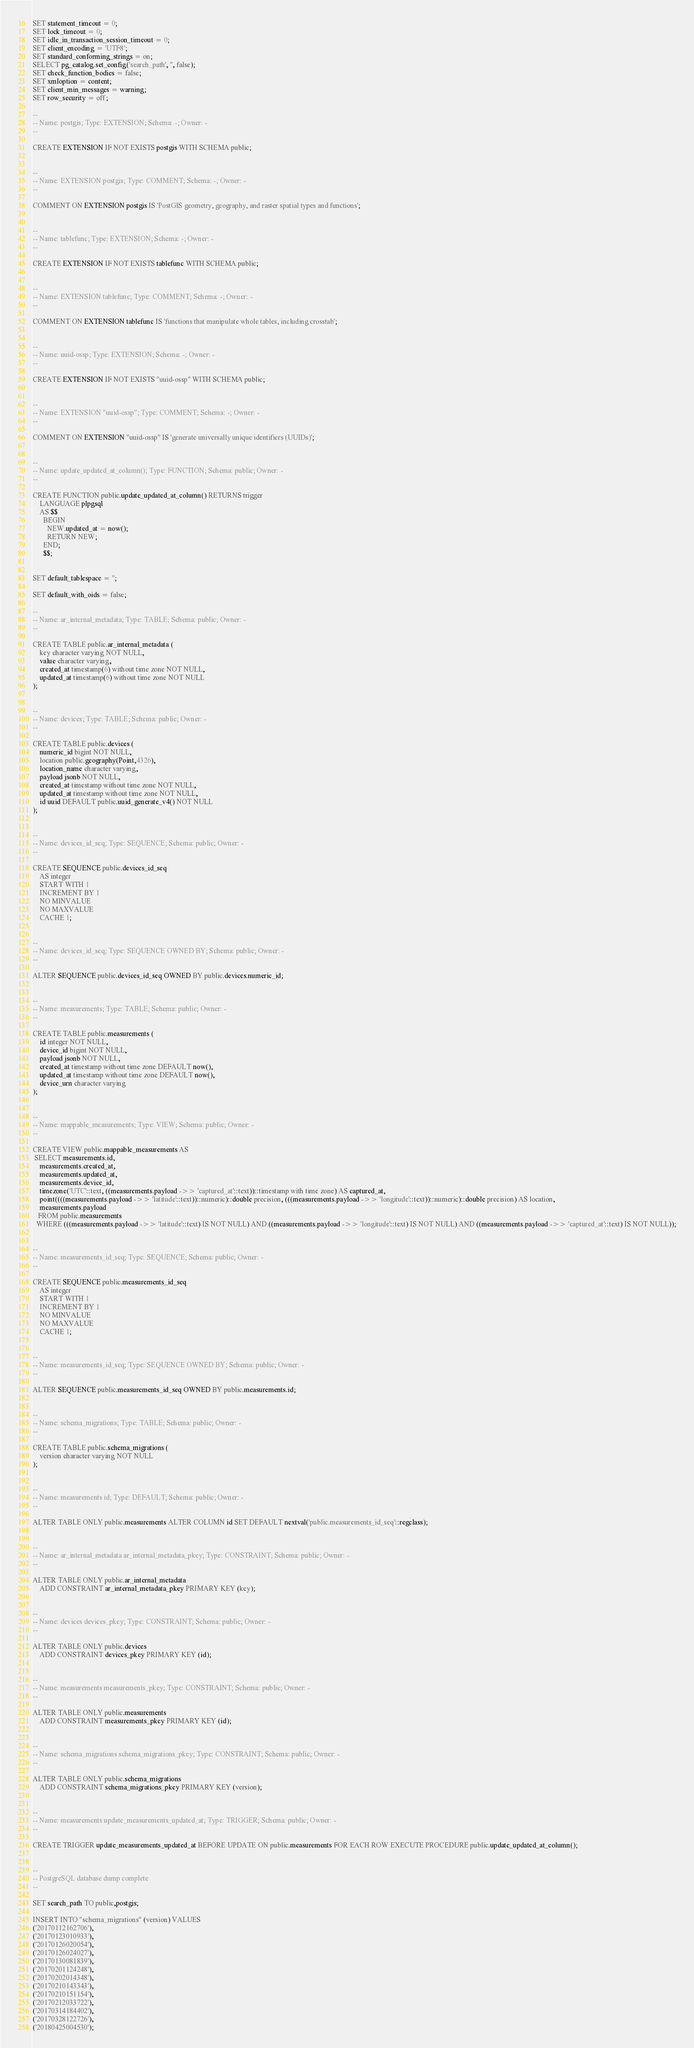<code> <loc_0><loc_0><loc_500><loc_500><_SQL_>SET statement_timeout = 0;
SET lock_timeout = 0;
SET idle_in_transaction_session_timeout = 0;
SET client_encoding = 'UTF8';
SET standard_conforming_strings = on;
SELECT pg_catalog.set_config('search_path', '', false);
SET check_function_bodies = false;
SET xmloption = content;
SET client_min_messages = warning;
SET row_security = off;

--
-- Name: postgis; Type: EXTENSION; Schema: -; Owner: -
--

CREATE EXTENSION IF NOT EXISTS postgis WITH SCHEMA public;


--
-- Name: EXTENSION postgis; Type: COMMENT; Schema: -; Owner: -
--

COMMENT ON EXTENSION postgis IS 'PostGIS geometry, geography, and raster spatial types and functions';


--
-- Name: tablefunc; Type: EXTENSION; Schema: -; Owner: -
--

CREATE EXTENSION IF NOT EXISTS tablefunc WITH SCHEMA public;


--
-- Name: EXTENSION tablefunc; Type: COMMENT; Schema: -; Owner: -
--

COMMENT ON EXTENSION tablefunc IS 'functions that manipulate whole tables, including crosstab';


--
-- Name: uuid-ossp; Type: EXTENSION; Schema: -; Owner: -
--

CREATE EXTENSION IF NOT EXISTS "uuid-ossp" WITH SCHEMA public;


--
-- Name: EXTENSION "uuid-ossp"; Type: COMMENT; Schema: -; Owner: -
--

COMMENT ON EXTENSION "uuid-ossp" IS 'generate universally unique identifiers (UUIDs)';


--
-- Name: update_updated_at_column(); Type: FUNCTION; Schema: public; Owner: -
--

CREATE FUNCTION public.update_updated_at_column() RETURNS trigger
    LANGUAGE plpgsql
    AS $$
      BEGIN
        NEW.updated_at = now();
        RETURN NEW;
      END;
      $$;


SET default_tablespace = '';

SET default_with_oids = false;

--
-- Name: ar_internal_metadata; Type: TABLE; Schema: public; Owner: -
--

CREATE TABLE public.ar_internal_metadata (
    key character varying NOT NULL,
    value character varying,
    created_at timestamp(6) without time zone NOT NULL,
    updated_at timestamp(6) without time zone NOT NULL
);


--
-- Name: devices; Type: TABLE; Schema: public; Owner: -
--

CREATE TABLE public.devices (
    numeric_id bigint NOT NULL,
    location public.geography(Point,4326),
    location_name character varying,
    payload jsonb NOT NULL,
    created_at timestamp without time zone NOT NULL,
    updated_at timestamp without time zone NOT NULL,
    id uuid DEFAULT public.uuid_generate_v4() NOT NULL
);


--
-- Name: devices_id_seq; Type: SEQUENCE; Schema: public; Owner: -
--

CREATE SEQUENCE public.devices_id_seq
    AS integer
    START WITH 1
    INCREMENT BY 1
    NO MINVALUE
    NO MAXVALUE
    CACHE 1;


--
-- Name: devices_id_seq; Type: SEQUENCE OWNED BY; Schema: public; Owner: -
--

ALTER SEQUENCE public.devices_id_seq OWNED BY public.devices.numeric_id;


--
-- Name: measurements; Type: TABLE; Schema: public; Owner: -
--

CREATE TABLE public.measurements (
    id integer NOT NULL,
    device_id bigint NOT NULL,
    payload jsonb NOT NULL,
    created_at timestamp without time zone DEFAULT now(),
    updated_at timestamp without time zone DEFAULT now(),
    device_urn character varying
);


--
-- Name: mappable_measurements; Type: VIEW; Schema: public; Owner: -
--

CREATE VIEW public.mappable_measurements AS
 SELECT measurements.id,
    measurements.created_at,
    measurements.updated_at,
    measurements.device_id,
    timezone('UTC'::text, ((measurements.payload ->> 'captured_at'::text))::timestamp with time zone) AS captured_at,
    point((((measurements.payload ->> 'latitude'::text))::numeric)::double precision, (((measurements.payload ->> 'longitude'::text))::numeric)::double precision) AS location,
    measurements.payload
   FROM public.measurements
  WHERE (((measurements.payload ->> 'latitude'::text) IS NOT NULL) AND ((measurements.payload ->> 'longitude'::text) IS NOT NULL) AND ((measurements.payload ->> 'captured_at'::text) IS NOT NULL));


--
-- Name: measurements_id_seq; Type: SEQUENCE; Schema: public; Owner: -
--

CREATE SEQUENCE public.measurements_id_seq
    AS integer
    START WITH 1
    INCREMENT BY 1
    NO MINVALUE
    NO MAXVALUE
    CACHE 1;


--
-- Name: measurements_id_seq; Type: SEQUENCE OWNED BY; Schema: public; Owner: -
--

ALTER SEQUENCE public.measurements_id_seq OWNED BY public.measurements.id;


--
-- Name: schema_migrations; Type: TABLE; Schema: public; Owner: -
--

CREATE TABLE public.schema_migrations (
    version character varying NOT NULL
);


--
-- Name: measurements id; Type: DEFAULT; Schema: public; Owner: -
--

ALTER TABLE ONLY public.measurements ALTER COLUMN id SET DEFAULT nextval('public.measurements_id_seq'::regclass);


--
-- Name: ar_internal_metadata ar_internal_metadata_pkey; Type: CONSTRAINT; Schema: public; Owner: -
--

ALTER TABLE ONLY public.ar_internal_metadata
    ADD CONSTRAINT ar_internal_metadata_pkey PRIMARY KEY (key);


--
-- Name: devices devices_pkey; Type: CONSTRAINT; Schema: public; Owner: -
--

ALTER TABLE ONLY public.devices
    ADD CONSTRAINT devices_pkey PRIMARY KEY (id);


--
-- Name: measurements measurements_pkey; Type: CONSTRAINT; Schema: public; Owner: -
--

ALTER TABLE ONLY public.measurements
    ADD CONSTRAINT measurements_pkey PRIMARY KEY (id);


--
-- Name: schema_migrations schema_migrations_pkey; Type: CONSTRAINT; Schema: public; Owner: -
--

ALTER TABLE ONLY public.schema_migrations
    ADD CONSTRAINT schema_migrations_pkey PRIMARY KEY (version);


--
-- Name: measurements update_measurements_updated_at; Type: TRIGGER; Schema: public; Owner: -
--

CREATE TRIGGER update_measurements_updated_at BEFORE UPDATE ON public.measurements FOR EACH ROW EXECUTE PROCEDURE public.update_updated_at_column();


--
-- PostgreSQL database dump complete
--

SET search_path TO public,postgis;

INSERT INTO "schema_migrations" (version) VALUES
('20170112162706'),
('20170123010933'),
('20170126020054'),
('20170126024027'),
('20170130081839'),
('20170201124248'),
('20170202014348'),
('20170210143343'),
('20170210151154'),
('20170212033722'),
('20170314184402'),
('20170328122726'),
('20180425004530');


</code> 